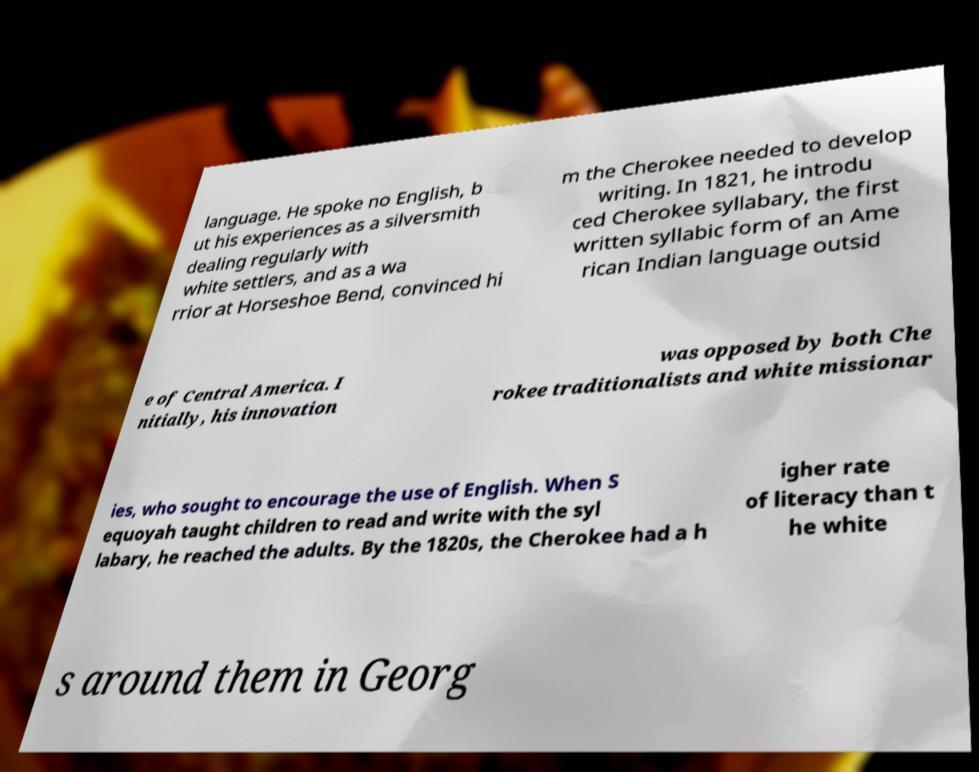I need the written content from this picture converted into text. Can you do that? language. He spoke no English, b ut his experiences as a silversmith dealing regularly with white settlers, and as a wa rrior at Horseshoe Bend, convinced hi m the Cherokee needed to develop writing. In 1821, he introdu ced Cherokee syllabary, the first written syllabic form of an Ame rican Indian language outsid e of Central America. I nitially, his innovation was opposed by both Che rokee traditionalists and white missionar ies, who sought to encourage the use of English. When S equoyah taught children to read and write with the syl labary, he reached the adults. By the 1820s, the Cherokee had a h igher rate of literacy than t he white s around them in Georg 